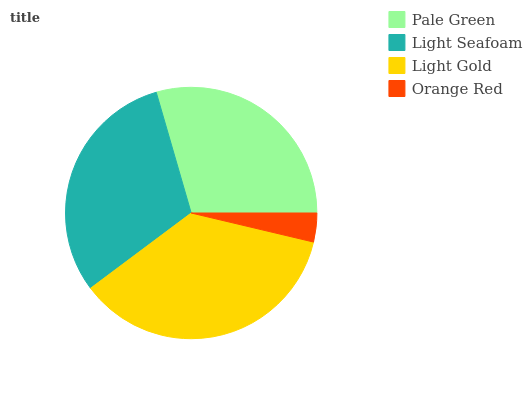Is Orange Red the minimum?
Answer yes or no. Yes. Is Light Gold the maximum?
Answer yes or no. Yes. Is Light Seafoam the minimum?
Answer yes or no. No. Is Light Seafoam the maximum?
Answer yes or no. No. Is Light Seafoam greater than Pale Green?
Answer yes or no. Yes. Is Pale Green less than Light Seafoam?
Answer yes or no. Yes. Is Pale Green greater than Light Seafoam?
Answer yes or no. No. Is Light Seafoam less than Pale Green?
Answer yes or no. No. Is Light Seafoam the high median?
Answer yes or no. Yes. Is Pale Green the low median?
Answer yes or no. Yes. Is Light Gold the high median?
Answer yes or no. No. Is Light Gold the low median?
Answer yes or no. No. 